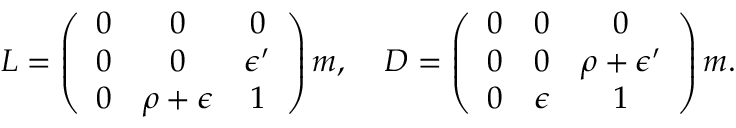<formula> <loc_0><loc_0><loc_500><loc_500>L = \left ( \begin{array} { c c c } { 0 } & { 0 } & { 0 } \\ { 0 } & { 0 } & { { \epsilon ^ { \prime } } } \\ { 0 } & { \rho + \epsilon } & { 1 } \end{array} \right ) m , \, D = \left ( \begin{array} { c c c } { 0 } & { 0 } & { 0 } \\ { 0 } & { 0 } & { { \rho + \epsilon ^ { \prime } } } \\ { 0 } & { \epsilon } & { 1 } \end{array} \right ) m .</formula> 